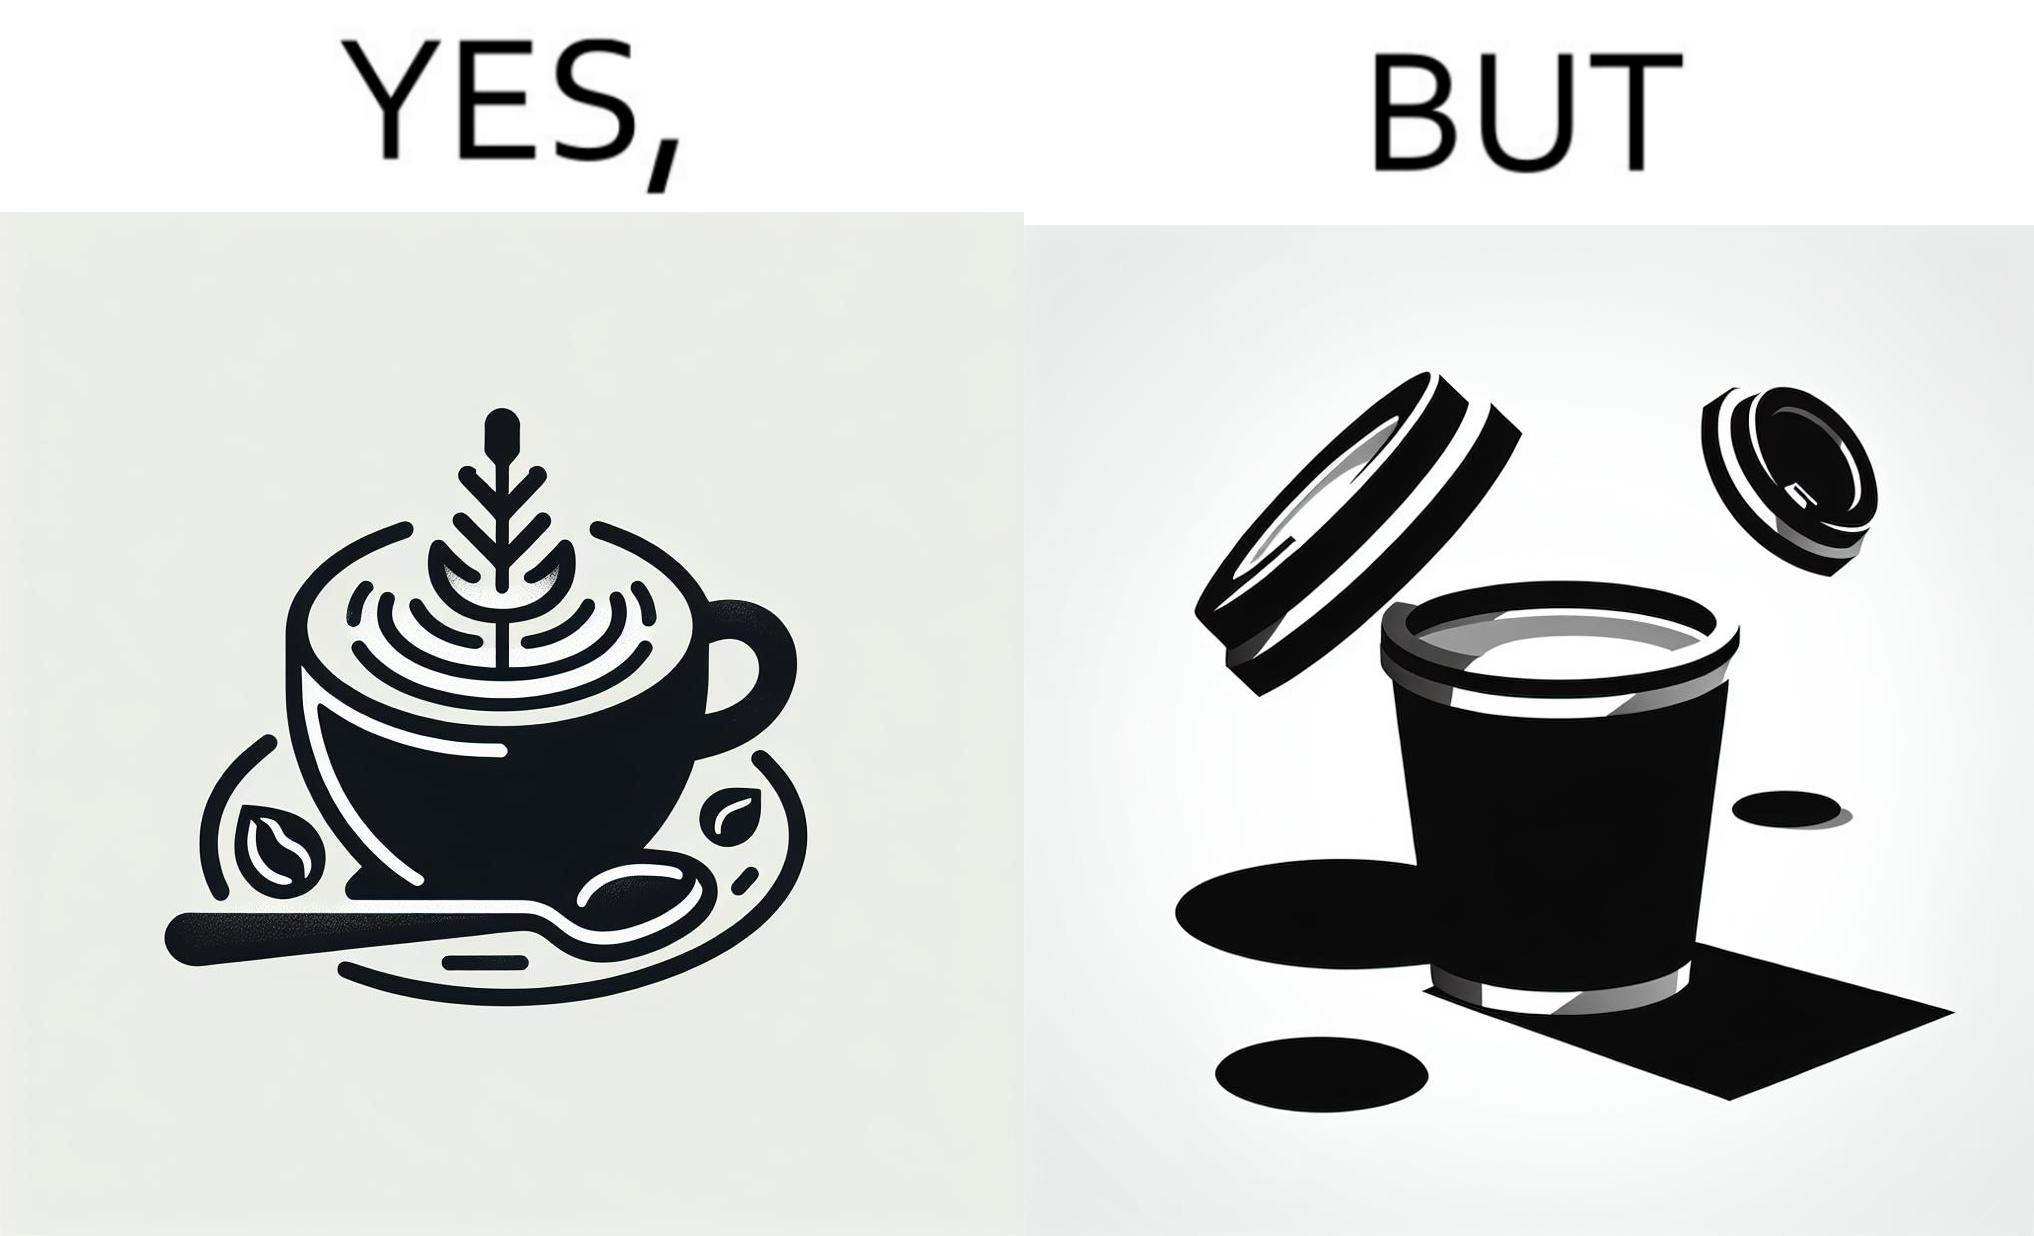Describe what you see in this image. The images are funny since it shows how someone has put effort into a cup of coffee to do latte art on it only for it to be invisible after a lid is put on the coffee cup before serving to a customer 